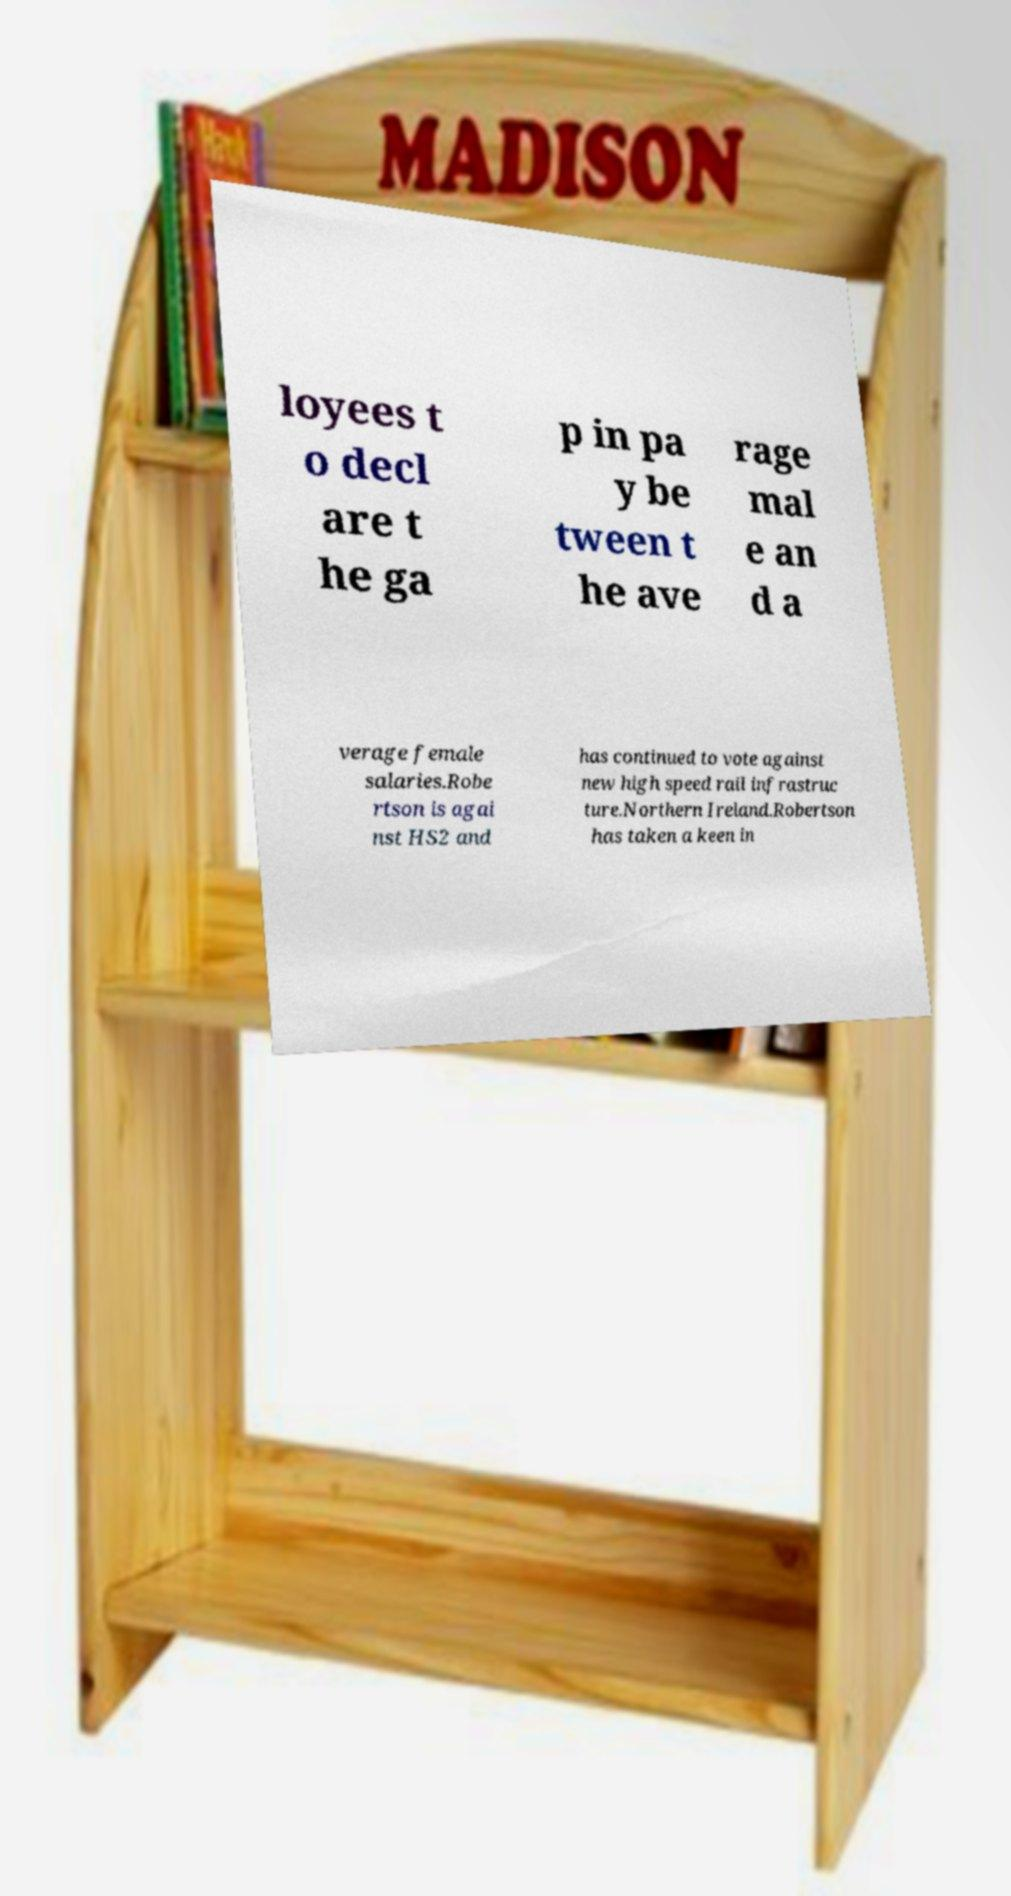Can you read and provide the text displayed in the image?This photo seems to have some interesting text. Can you extract and type it out for me? loyees t o decl are t he ga p in pa y be tween t he ave rage mal e an d a verage female salaries.Robe rtson is agai nst HS2 and has continued to vote against new high speed rail infrastruc ture.Northern Ireland.Robertson has taken a keen in 